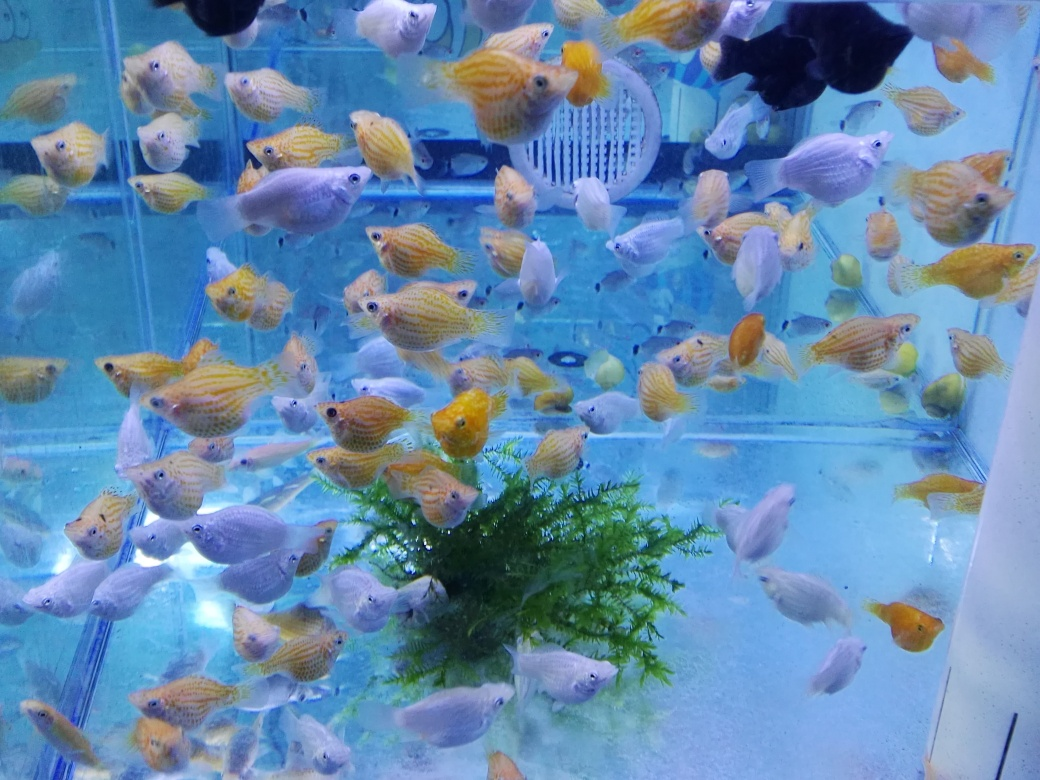How do you maintain an aquarium with so many fish healthy? Keeping an aquarium healthy with a high population of fish requires meticulous attention to water quality, including parameters like pH levels and ammonia content. Regular cleaning, filtration, and water changes are essential. A balanced diet and proper tank sizing also play crucial roles in maintaining the health and well-being of the fish. 